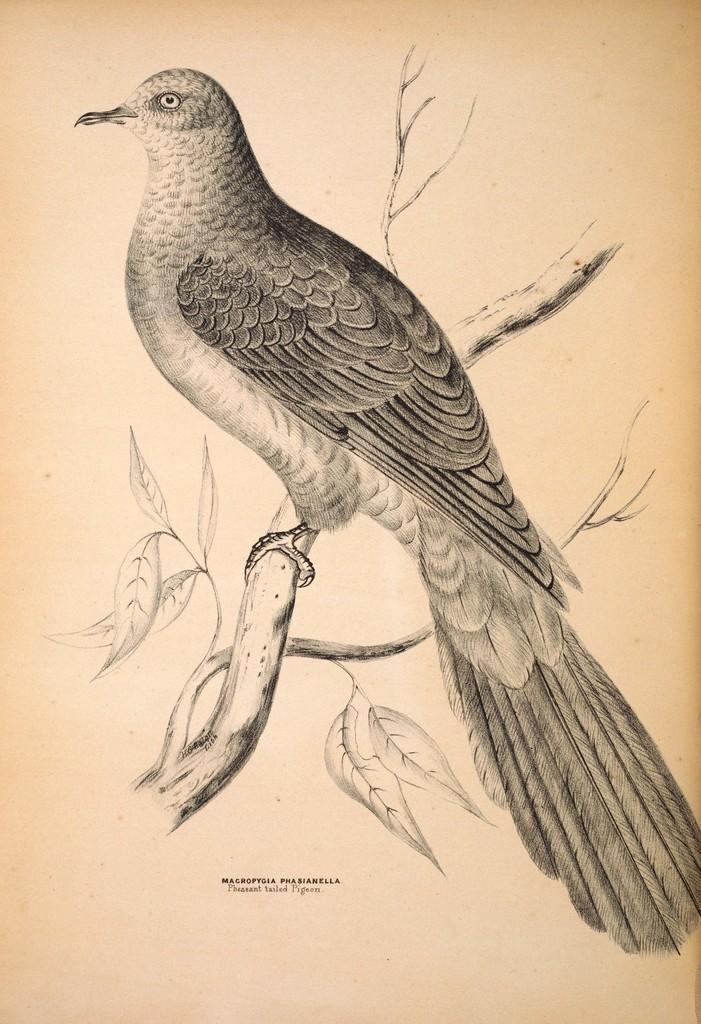How would you summarize this image in a sentence or two? This is a picture of a drawing. In this picture we can see a bird, branches, leaves. At the bottom portion of the picture there is something written. 